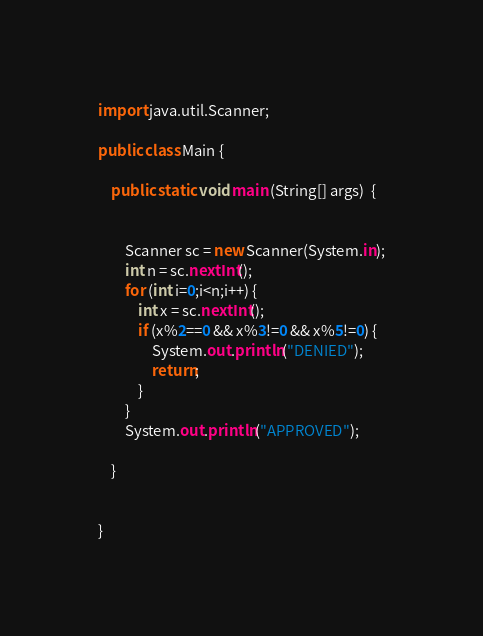<code> <loc_0><loc_0><loc_500><loc_500><_Java_>

import java.util.Scanner;

public class Main {

	public static void main (String[] args)  {


		Scanner sc = new Scanner(System.in);
		int n = sc.nextInt();
		for (int i=0;i<n;i++) {
			int x = sc.nextInt();
			if (x%2==0 && x%3!=0 && x%5!=0) {
				System.out.println("DENIED");
				return;
			}
		}
		System.out.println("APPROVED");

	}


}
</code> 